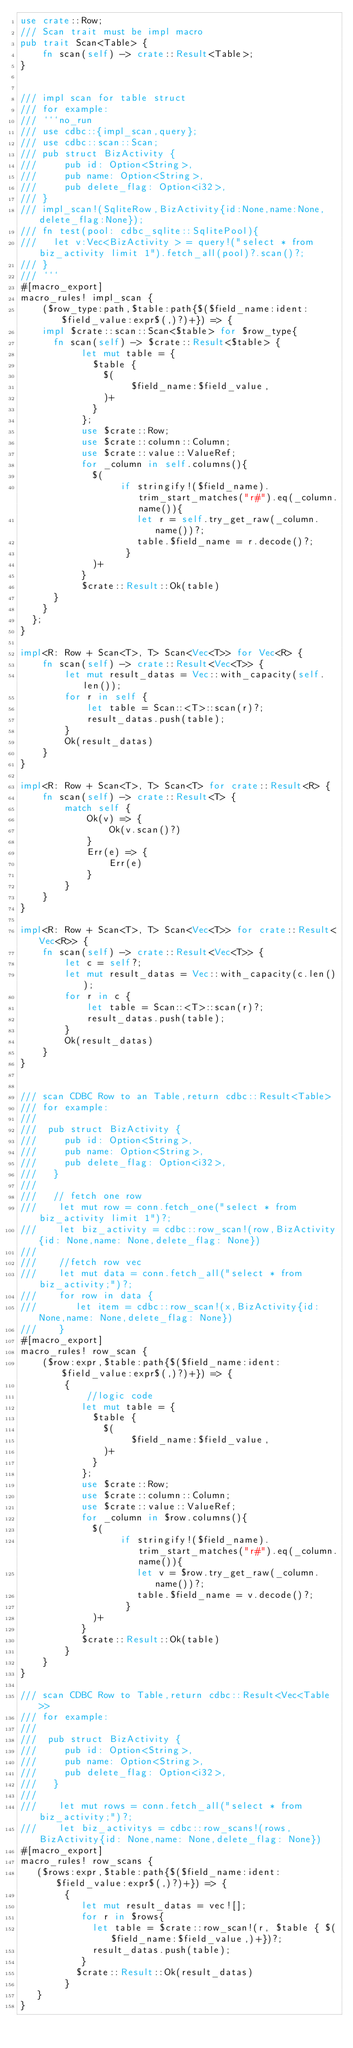<code> <loc_0><loc_0><loc_500><loc_500><_Rust_>use crate::Row;
/// Scan trait must be impl macro
pub trait Scan<Table> {
    fn scan(self) -> crate::Result<Table>;
}


/// impl scan for table struct
/// for example:
/// ```no_run
/// use cdbc::{impl_scan,query};
/// use cdbc::scan::Scan;
/// pub struct BizActivity {
///     pub id: Option<String>,
///     pub name: Option<String>,
///     pub delete_flag: Option<i32>,
/// }
/// impl_scan!(SqliteRow,BizActivity{id:None,name:None,delete_flag:None});
/// fn test(pool: cdbc_sqlite::SqlitePool){
///   let v:Vec<BizActivity > = query!("select * from biz_activity limit 1").fetch_all(pool)?.scan()?;
/// }
/// ```
#[macro_export]
macro_rules! impl_scan {
    ($row_type:path,$table:path{$($field_name:ident: $field_value:expr$(,)?)+}) => {
    impl $crate::scan::Scan<$table> for $row_type{
      fn scan(self) -> $crate::Result<$table> {
           let mut table = {
             $table {
               $(
                    $field_name:$field_value,
               )+
             }
           };
           use $crate::Row;
           use $crate::column::Column;
           use $crate::value::ValueRef;
           for _column in self.columns(){
             $(
                  if stringify!($field_name).trim_start_matches("r#").eq(_column.name()){
                     let r = self.try_get_raw(_column.name())?;
                     table.$field_name = r.decode()?;
                   }
             )+
           }
           $crate::Result::Ok(table)
      }
    }
  };
}

impl<R: Row + Scan<T>, T> Scan<Vec<T>> for Vec<R> {
    fn scan(self) -> crate::Result<Vec<T>> {
        let mut result_datas = Vec::with_capacity(self.len());
        for r in self {
            let table = Scan::<T>::scan(r)?;
            result_datas.push(table);
        }
        Ok(result_datas)
    }
}

impl<R: Row + Scan<T>, T> Scan<T> for crate::Result<R> {
    fn scan(self) -> crate::Result<T> {
        match self {
            Ok(v) => {
                Ok(v.scan()?)
            }
            Err(e) => {
                Err(e)
            }
        }
    }
}

impl<R: Row + Scan<T>, T> Scan<Vec<T>> for crate::Result<Vec<R>> {
    fn scan(self) -> crate::Result<Vec<T>> {
        let c = self?;
        let mut result_datas = Vec::with_capacity(c.len());
        for r in c {
            let table = Scan::<T>::scan(r)?;
            result_datas.push(table);
        }
        Ok(result_datas)
    }
}


/// scan CDBC Row to an Table,return cdbc::Result<Table>
/// for example:
///
///  pub struct BizActivity {
///     pub id: Option<String>,
///     pub name: Option<String>,
///     pub delete_flag: Option<i32>,
///   }
///
///   // fetch one row
///    let mut row = conn.fetch_one("select * from biz_activity limit 1")?;
///    let biz_activity = cdbc::row_scan!(row,BizActivity{id: None,name: None,delete_flag: None})
///
///    //fetch row vec
///    let mut data = conn.fetch_all("select * from biz_activity;")?;
///    for row in data {
///       let item = cdbc::row_scan!(x,BizActivity{id: None,name: None,delete_flag: None})
///    }
#[macro_export]
macro_rules! row_scan {
    ($row:expr,$table:path{$($field_name:ident: $field_value:expr$(,)?)+}) => {
        {
            //logic code
           let mut table = {
             $table {
               $(
                    $field_name:$field_value,
               )+
             }
           };
           use $crate::Row;
           use $crate::column::Column;
           use $crate::value::ValueRef;
           for _column in $row.columns(){
             $(
                  if stringify!($field_name).trim_start_matches("r#").eq(_column.name()){
                     let v = $row.try_get_raw(_column.name())?;
                     table.$field_name = v.decode()?;
                   }
             )+
           }
           $crate::Result::Ok(table)
        }
    }
}

/// scan CDBC Row to Table,return cdbc::Result<Vec<Table>>
/// for example:
///
///  pub struct BizActivity {
///     pub id: Option<String>,
///     pub name: Option<String>,
///     pub delete_flag: Option<i32>,
///   }
///
///    let mut rows = conn.fetch_all("select * from biz_activity;")?;
///    let biz_activitys = cdbc::row_scans!(rows,BizActivity{id: None,name: None,delete_flag: None})
#[macro_export]
macro_rules! row_scans {
   ($rows:expr,$table:path{$($field_name:ident: $field_value:expr$(,)?)+}) => {
        {
           let mut result_datas = vec![];
           for r in $rows{
             let table = $crate::row_scan!(r, $table { $($field_name:$field_value,)+})?;
             result_datas.push(table);
           }
          $crate::Result::Ok(result_datas)
        }
   }
}</code> 